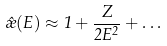<formula> <loc_0><loc_0><loc_500><loc_500>\hat { \rho } ( E ) \approx 1 + \frac { Z } { 2 E ^ { 2 } } + \dots</formula> 